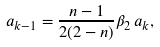<formula> <loc_0><loc_0><loc_500><loc_500>a _ { k - 1 } = \frac { n - 1 } { 2 ( 2 - n ) } \beta _ { 2 } \, a _ { k } ,</formula> 